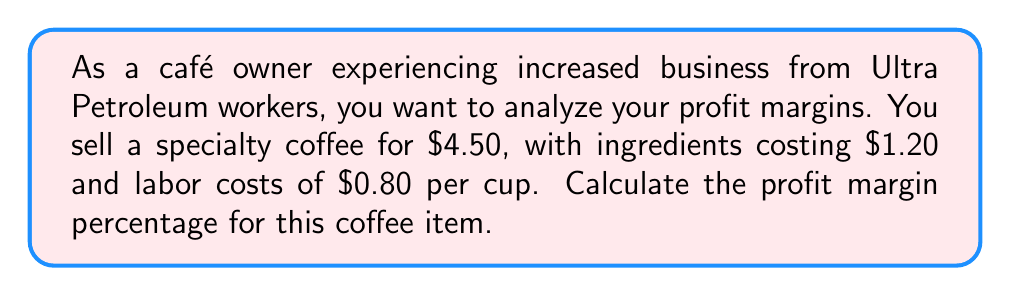Solve this math problem. To calculate the profit margin percentage, we need to follow these steps:

1. Calculate the total cost per item:
   Total cost = Ingredient cost + Labor cost
   $$ \text{Total cost} = $1.20 + $0.80 = $2.00 $$

2. Calculate the profit per item:
   Profit = Selling price - Total cost
   $$ \text{Profit} = $4.50 - $2.00 = $2.50 $$

3. Calculate the profit margin percentage:
   Profit margin percentage = (Profit / Selling price) × 100%
   $$ \text{Profit margin percentage} = \frac{\text{Profit}}{\text{Selling price}} \times 100\% $$
   $$ = \frac{$2.50}{$4.50} \times 100\% $$
   $$ = 0.5555... \times 100\% $$
   $$ \approx 55.56\% $$

The profit margin percentage is approximately 55.56%.
Answer: The profit margin percentage for the specialty coffee is 55.56%. 